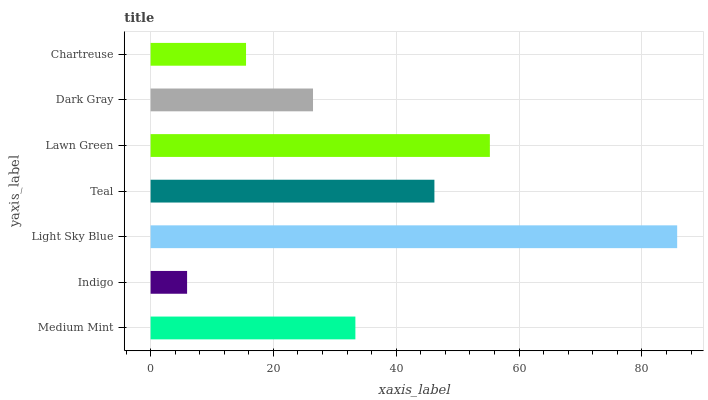Is Indigo the minimum?
Answer yes or no. Yes. Is Light Sky Blue the maximum?
Answer yes or no. Yes. Is Light Sky Blue the minimum?
Answer yes or no. No. Is Indigo the maximum?
Answer yes or no. No. Is Light Sky Blue greater than Indigo?
Answer yes or no. Yes. Is Indigo less than Light Sky Blue?
Answer yes or no. Yes. Is Indigo greater than Light Sky Blue?
Answer yes or no. No. Is Light Sky Blue less than Indigo?
Answer yes or no. No. Is Medium Mint the high median?
Answer yes or no. Yes. Is Medium Mint the low median?
Answer yes or no. Yes. Is Chartreuse the high median?
Answer yes or no. No. Is Light Sky Blue the low median?
Answer yes or no. No. 